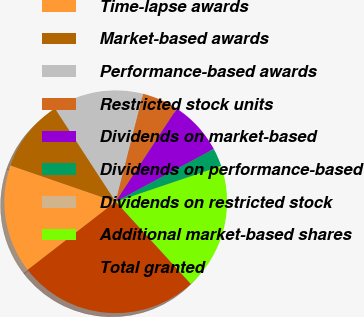Convert chart to OTSL. <chart><loc_0><loc_0><loc_500><loc_500><pie_chart><fcel>Time-lapse awards<fcel>Market-based awards<fcel>Performance-based awards<fcel>Restricted stock units<fcel>Dividends on market-based<fcel>Dividends on performance-based<fcel>Dividends on restricted stock<fcel>Additional market-based shares<fcel>Total granted<nl><fcel>15.78%<fcel>10.53%<fcel>13.15%<fcel>5.28%<fcel>7.9%<fcel>2.65%<fcel>0.02%<fcel>18.41%<fcel>26.28%<nl></chart> 